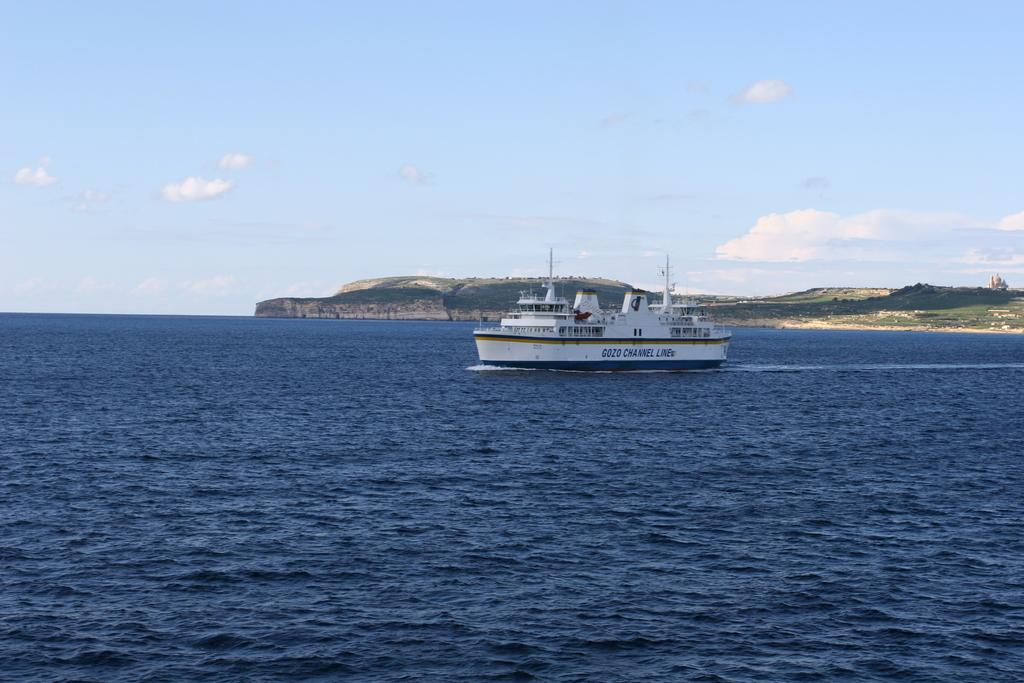What is the main subject of the image? There is a ship in the image. What is the ship doing in the image? The ship is moving in the sea. What can be seen in the background of the image? There is a hill in the background of the image. How would you describe the weather in the image? The sky is cloudy in the image. What is the rate at which the dime is spinning in the image? There is no dime present in the image, so it is not possible to determine the rate at which it might be spinning. 